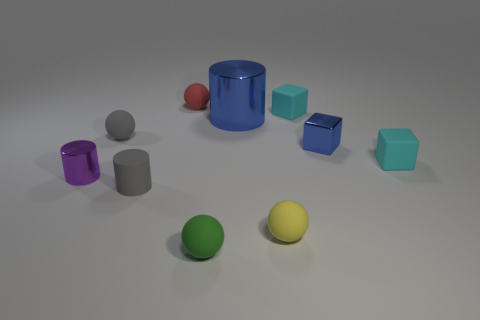Subtract all blue balls. Subtract all yellow blocks. How many balls are left? 4 Subtract all spheres. How many objects are left? 6 Subtract 0 cyan cylinders. How many objects are left? 10 Subtract all big objects. Subtract all small red matte cylinders. How many objects are left? 9 Add 4 spheres. How many spheres are left? 8 Add 7 tiny gray things. How many tiny gray things exist? 9 